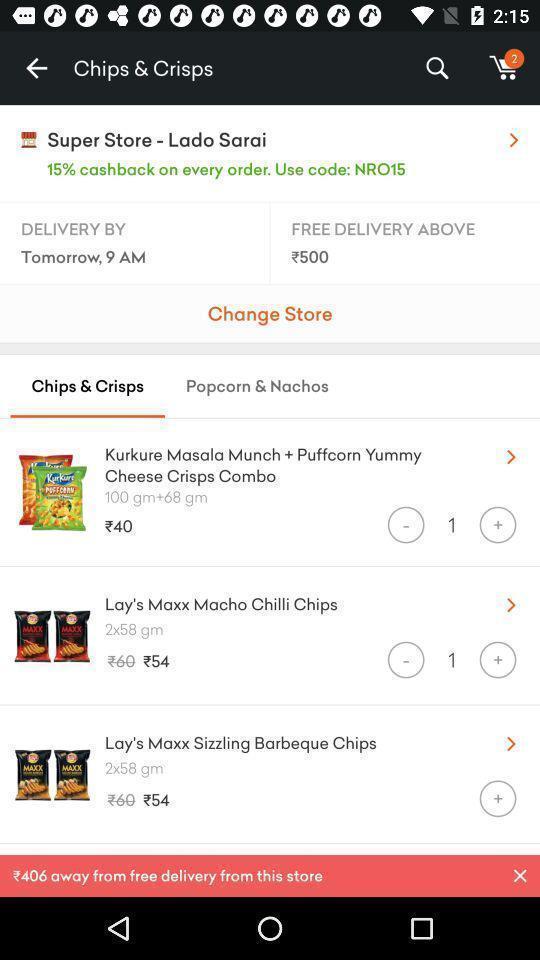Explain the elements present in this screenshot. List of various options in a grocery app. 